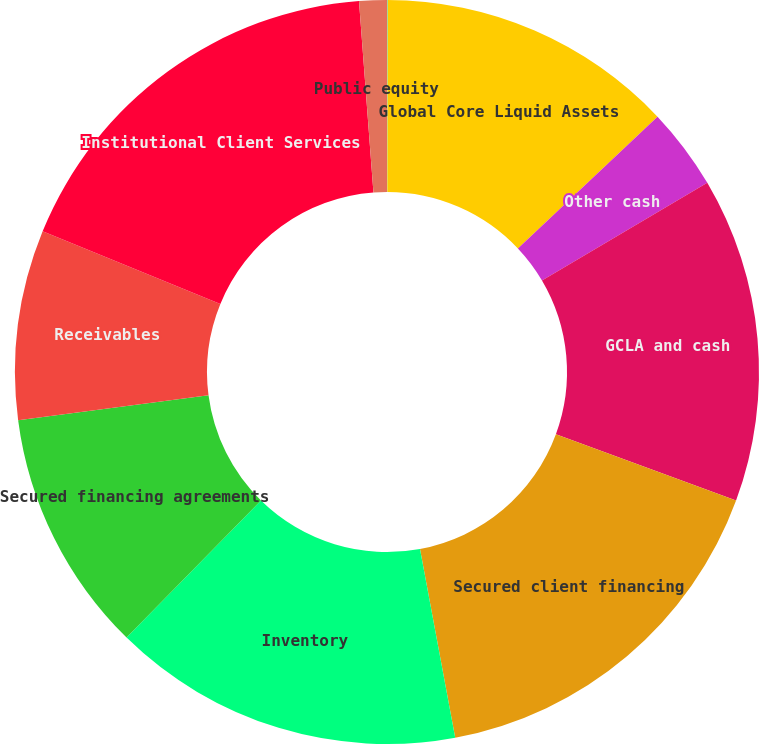Convert chart. <chart><loc_0><loc_0><loc_500><loc_500><pie_chart><fcel>in millions<fcel>Global Core Liquid Assets<fcel>Other cash<fcel>GCLA and cash<fcel>Secured client financing<fcel>Inventory<fcel>Secured financing agreements<fcel>Receivables<fcel>Institutional Client Services<fcel>Public equity<nl><fcel>0.03%<fcel>12.93%<fcel>3.55%<fcel>14.11%<fcel>16.45%<fcel>15.28%<fcel>10.59%<fcel>8.24%<fcel>17.63%<fcel>1.2%<nl></chart> 